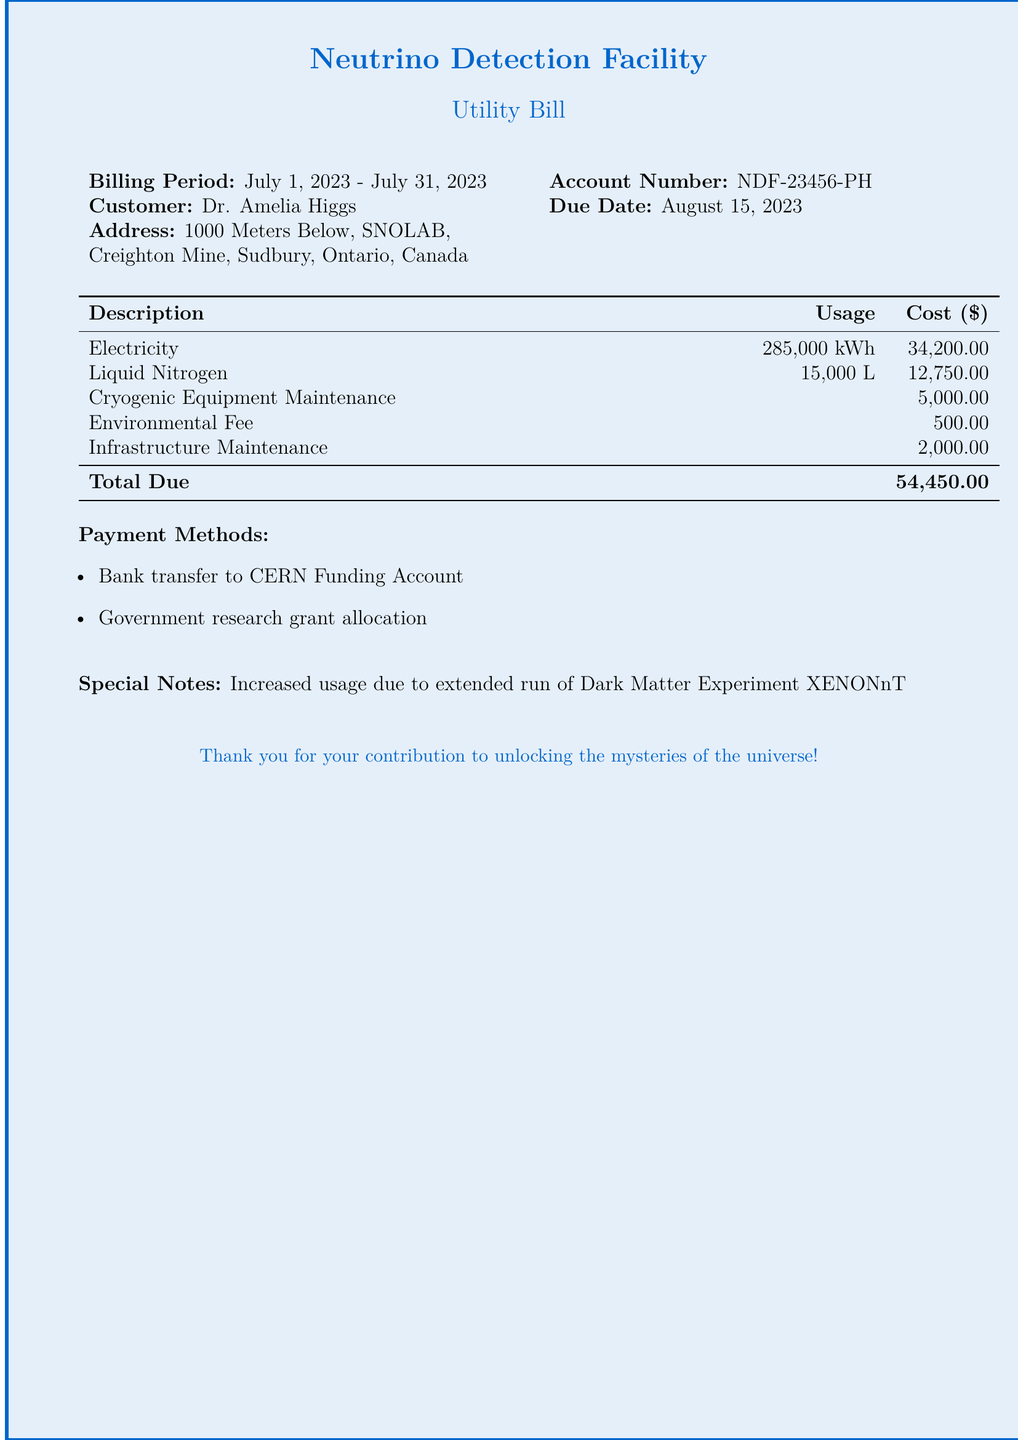what is the billing period? The billing period is specified at the top of the document, from July 1, 2023, to July 31, 2023.
Answer: July 1, 2023 - July 31, 2023 who is the customer? The customer's name is listed in the document as Dr. Amelia Higgs.
Answer: Dr. Amelia Higgs what is the total due amount? The total due is provided in the cost table at the bottom of the document and is the overall amount owed.
Answer: 54,450.00 how much was spent on electricity? The electricity cost is listed specifically in the breakdown section of the document.
Answer: 34,200.00 what additional fee is associated with environmental costs? The document lists an environmental fee alongside other maintenance costs.
Answer: 500.00 what is the main reason for increased usage in this bill? There is a special note indicating that the increased usage is due to a specific experiment.
Answer: Dark Matter Experiment XENONnT what payment methods are available? The document outlines specific payment methods available for this bill.
Answer: Bank transfer and Government research grant allocation how much liquid nitrogen was used? The usage of liquid nitrogen is indicated in the cost breakdown section, showing the total amount consumed.
Answer: 15,000 L what is the account number? The account number is provided in the header information of the document.
Answer: NDF-23456-PH 